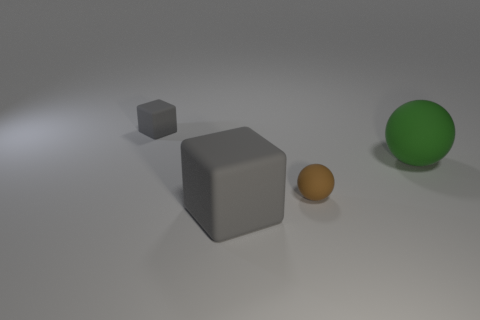Add 4 blue things. How many objects exist? 8 Subtract all brown spheres. How many spheres are left? 1 Subtract 1 cubes. How many cubes are left? 1 Subtract all purple balls. Subtract all blue cylinders. How many balls are left? 2 Subtract all brown cubes. How many green balls are left? 1 Subtract all tiny rubber cubes. Subtract all large matte things. How many objects are left? 1 Add 3 matte objects. How many matte objects are left? 7 Add 1 yellow matte cylinders. How many yellow matte cylinders exist? 1 Subtract 0 purple cylinders. How many objects are left? 4 